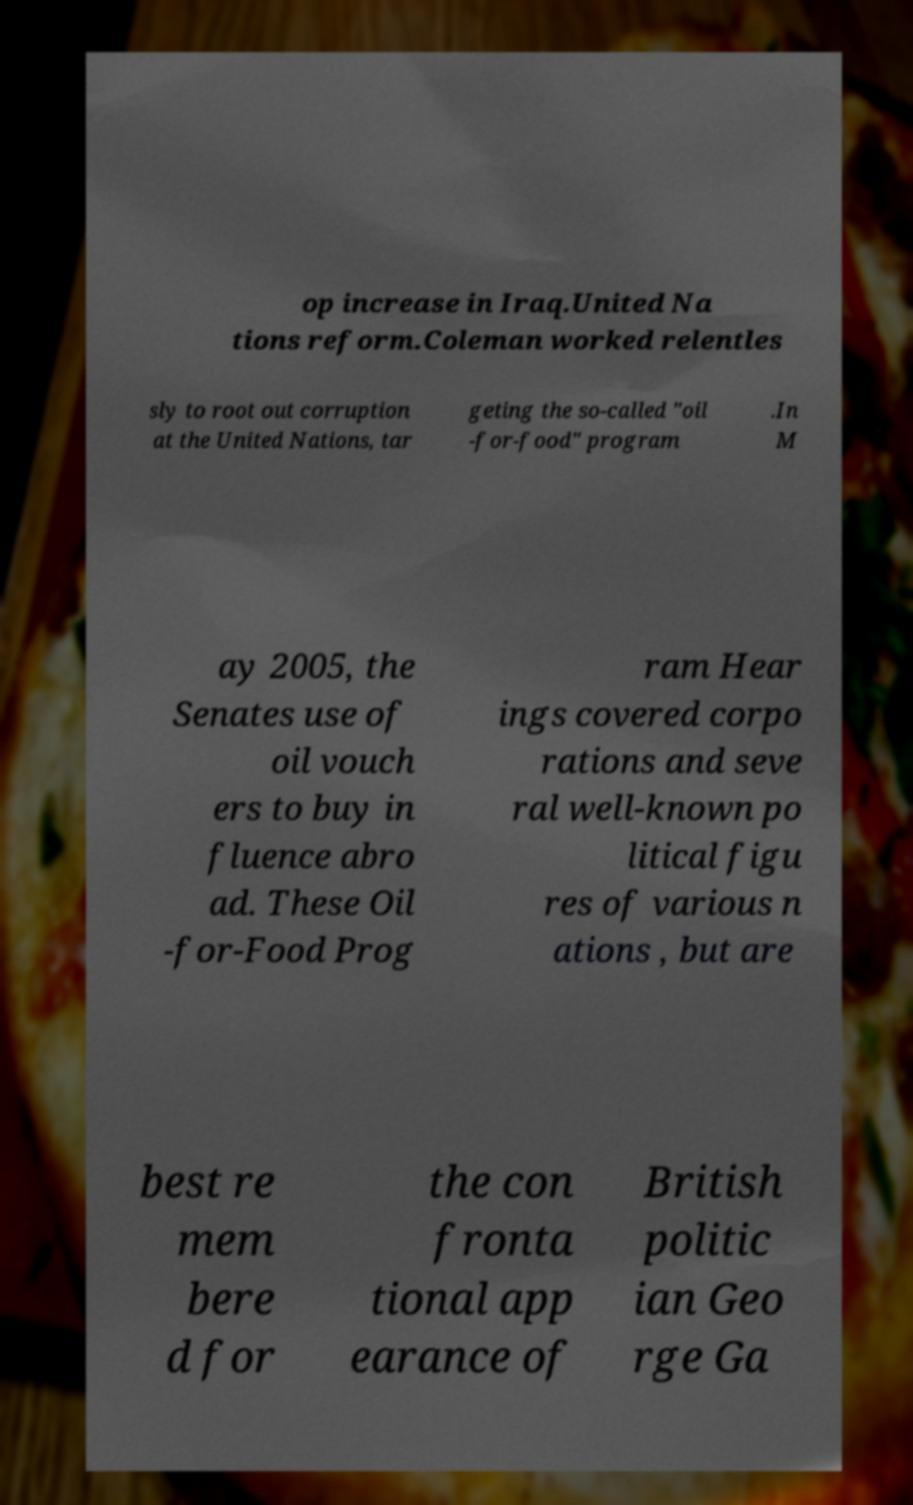Can you accurately transcribe the text from the provided image for me? op increase in Iraq.United Na tions reform.Coleman worked relentles sly to root out corruption at the United Nations, tar geting the so-called "oil -for-food" program .In M ay 2005, the Senates use of oil vouch ers to buy in fluence abro ad. These Oil -for-Food Prog ram Hear ings covered corpo rations and seve ral well-known po litical figu res of various n ations , but are best re mem bere d for the con fronta tional app earance of British politic ian Geo rge Ga 